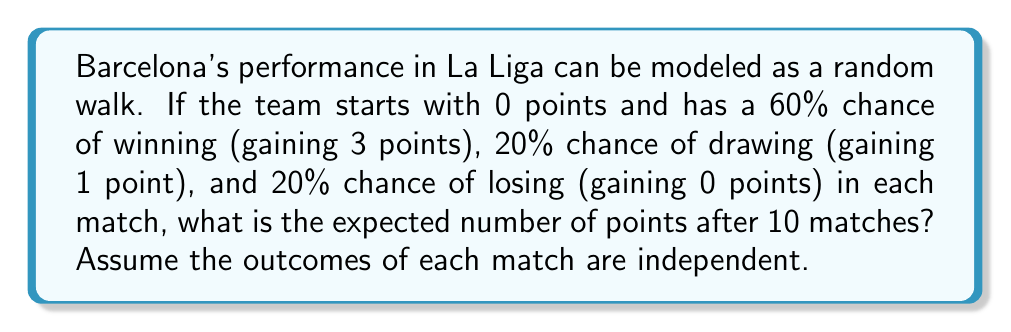Can you answer this question? Let's approach this step-by-step:

1) First, we need to calculate the expected points gained in a single match:
   
   $E[X] = 3 \cdot 0.6 + 1 \cdot 0.2 + 0 \cdot 0.2 = 1.8 + 0.2 = 2$ points

2) In a random walk, the expected position after n steps is n times the expected change in a single step. Here, n = 10 matches.

3) Therefore, the expected number of points after 10 matches is:

   $E[S_{10}] = 10 \cdot E[X] = 10 \cdot 2 = 20$ points

4) We can also calculate the variance of points in a single match:
   
   $Var(X) = E[X^2] - (E[X])^2$
   
   $E[X^2] = 3^2 \cdot 0.6 + 1^2 \cdot 0.2 + 0^2 \cdot 0.2 = 5.4 + 0.2 = 5.6$
   
   $Var(X) = 5.6 - 2^2 = 1.6$

5) The variance after 10 matches would be:

   $Var(S_{10}) = 10 \cdot Var(X) = 10 \cdot 1.6 = 16$

6) This gives us a standard deviation of $\sqrt{16} = 4$ points.

While this additional information about variance and standard deviation isn't necessary to answer the specific question, it provides insight into the potential spread of outcomes around the expected value.
Answer: 20 points 